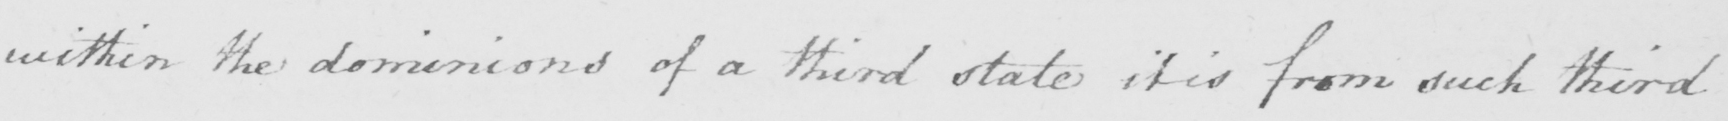Please transcribe the handwritten text in this image. within the dominions of a third state it is from such third 